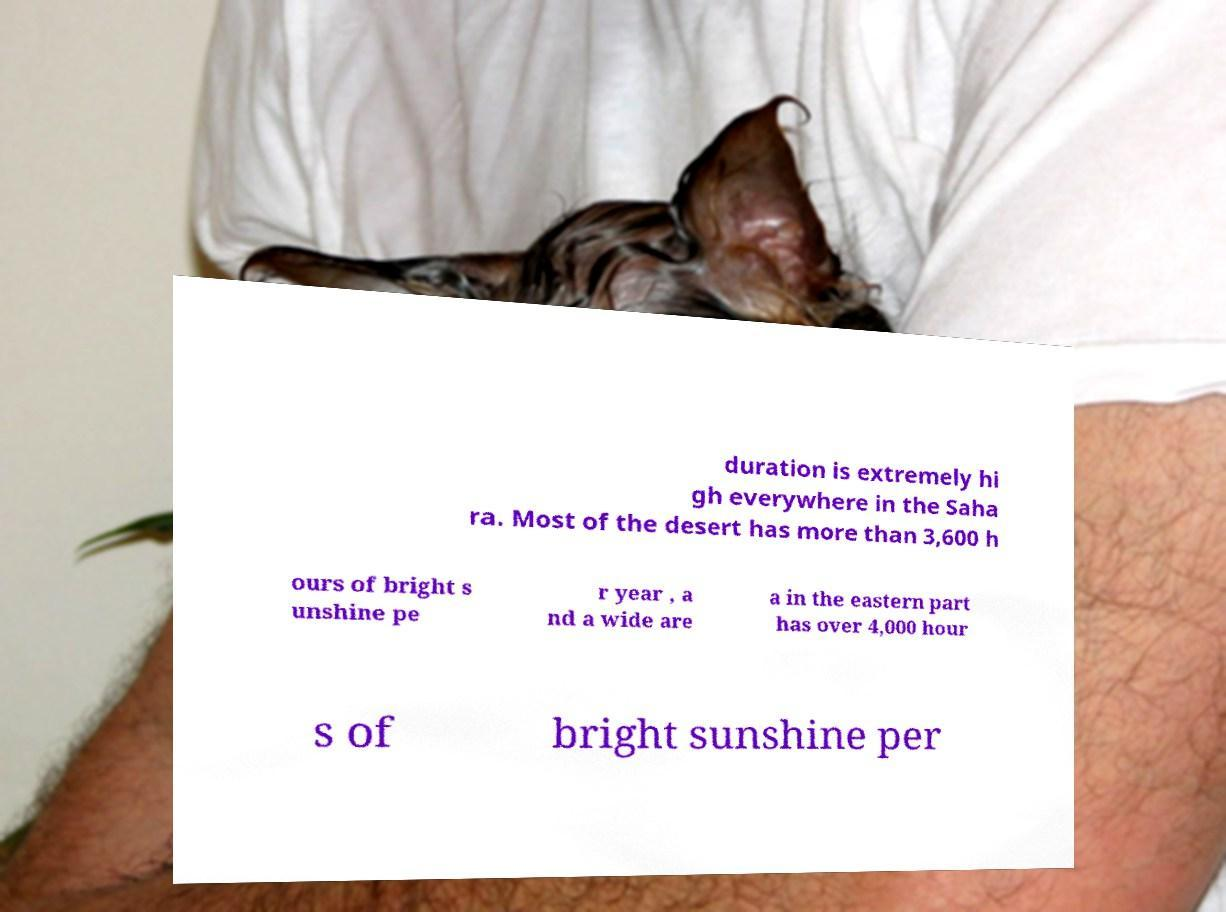Can you read and provide the text displayed in the image?This photo seems to have some interesting text. Can you extract and type it out for me? duration is extremely hi gh everywhere in the Saha ra. Most of the desert has more than 3,600 h ours of bright s unshine pe r year , a nd a wide are a in the eastern part has over 4,000 hour s of bright sunshine per 